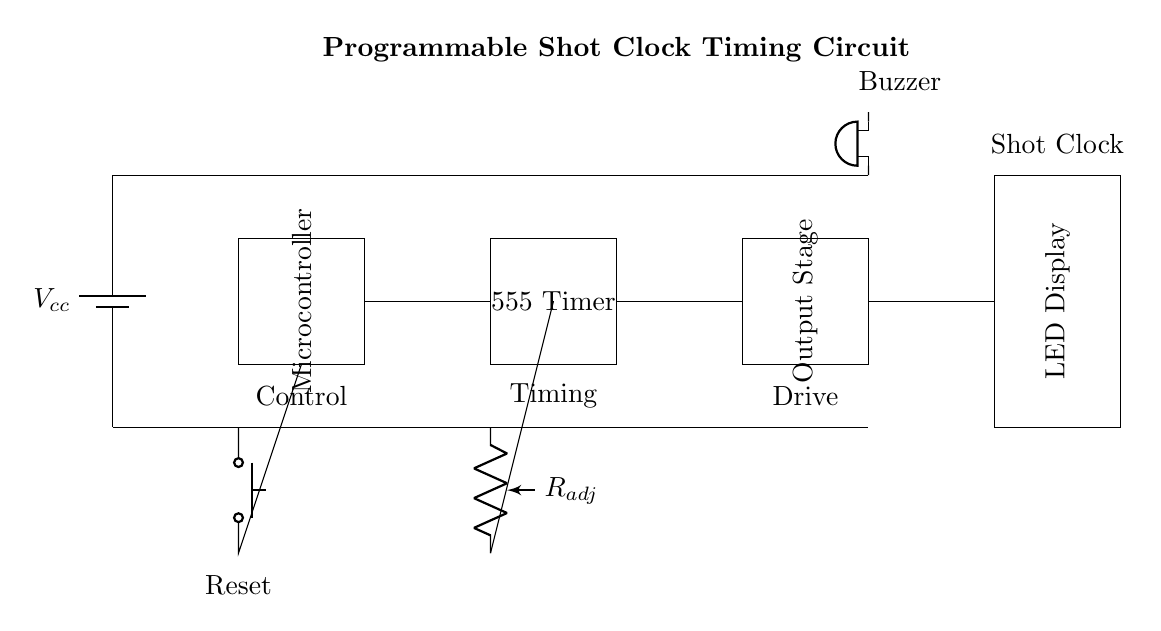What is the main function of the microcontroller? The microcontroller manages the timing operations and controls the logic of the shot clock system, allowing it to run and reset as needed.
Answer: Timing operations What component is used for adjustable timing? The component designated as R_adj is a potentiometer, which allows users to adjust the resistance and thereby modify the timing intervals of the shot clock.
Answer: Potentiometer How many main components are visible in the circuit? The circuit diagram shows four main components: the microcontroller, the 555 timer, the output stage, and the LED display.
Answer: Four What is the purpose of the buzzer in this circuit? The buzzer serves as an auditory signal to indicate the end of the shot clock time, alerting players and officials.
Answer: Auditory signal What type of timer is utilized in this circuit? The circuit incorporates a 555 timer, which is commonly used in timing applications for generating specific delay intervals.
Answer: 555 timer What happens when the reset button is pressed? Pressing the reset button will trigger the microcontroller to reset the timing count, effectively setting the shot clock back to its starting position.
Answer: Resets timing 